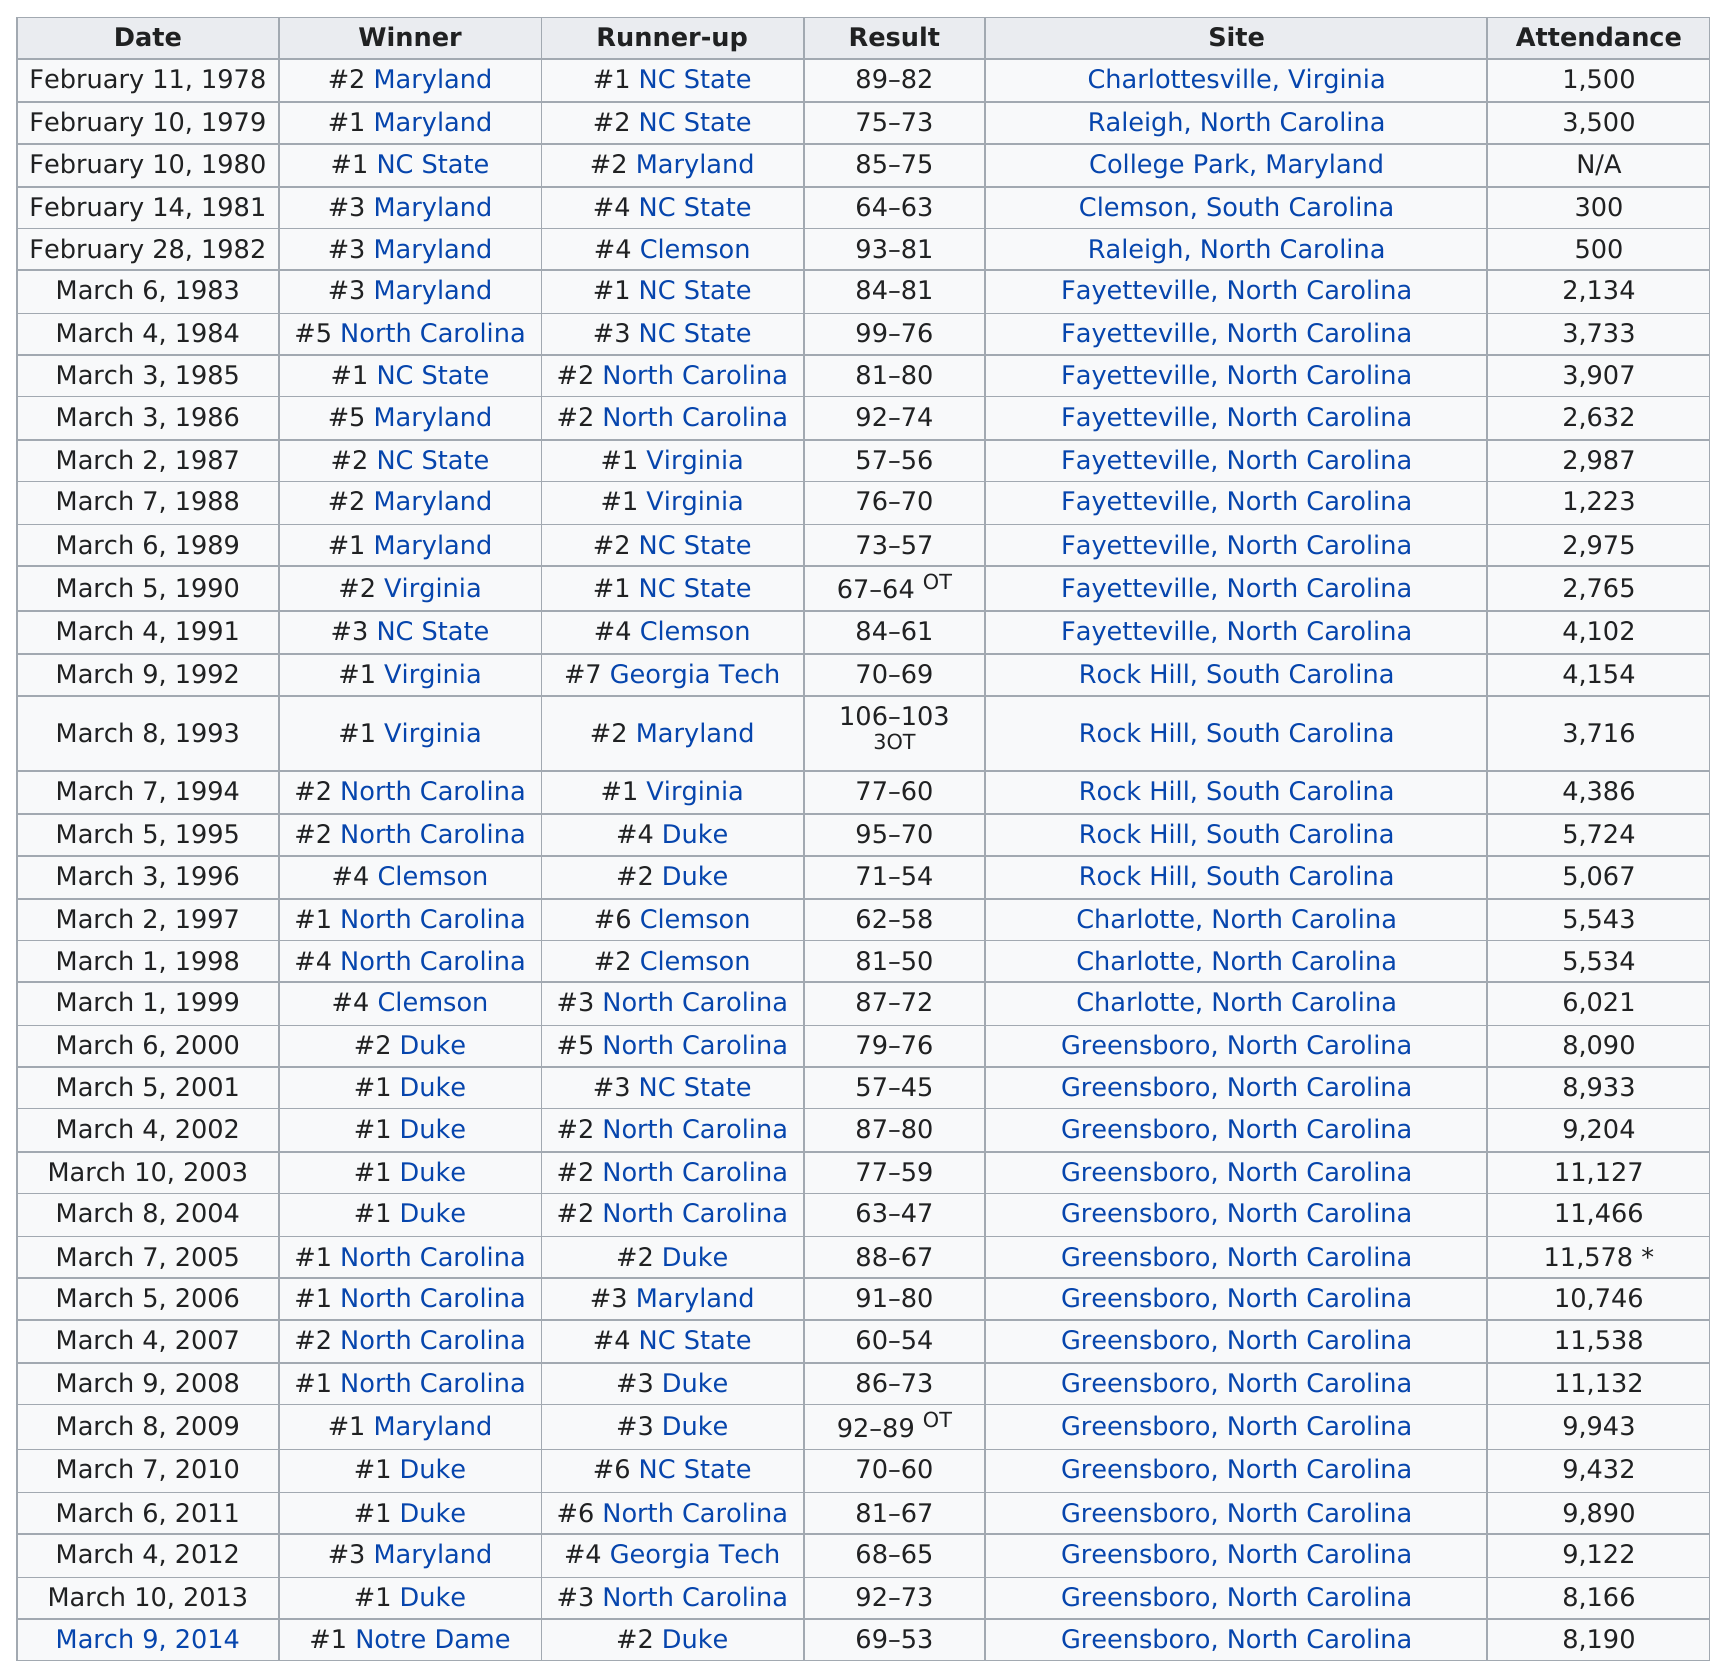Draw attention to some important aspects in this diagram. Clemson, South Carolina had the least amount of attendees. There was a difference of 2,000 attendees between the attendees in Maryland on February 10, 1979 and February 11, 1978. Maryland was the first team to be crowned champion of the tournament. NC State, the team that was ranked first and also won the 1985 ACC Women's Basketball Tournament, is the team in question. Duke placed first a total of eight times. 